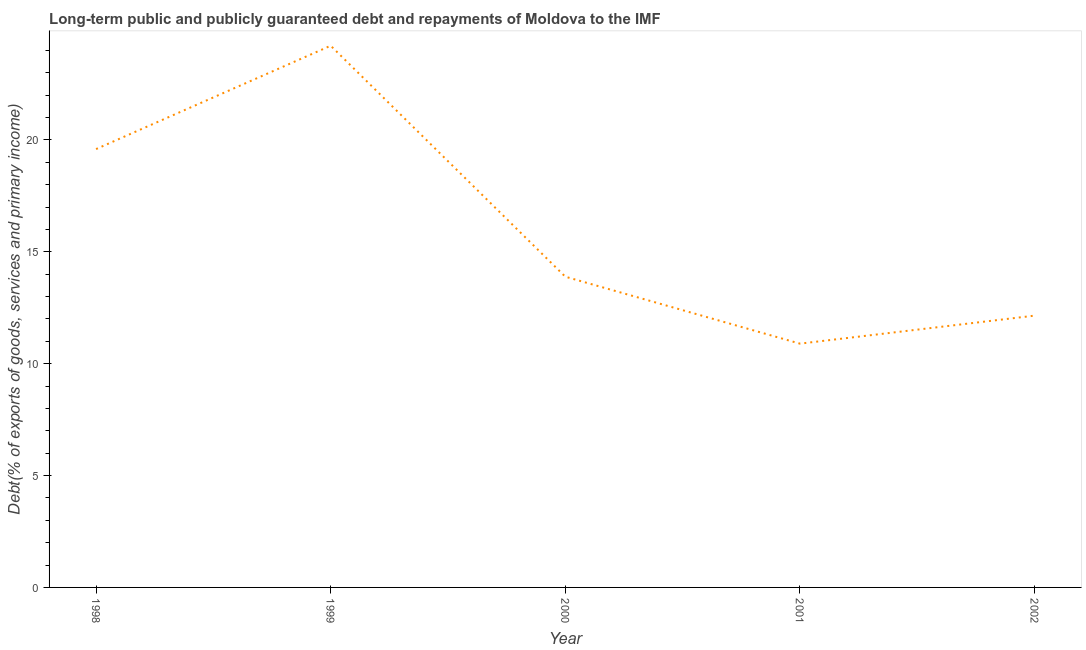What is the debt service in 2002?
Provide a short and direct response. 12.15. Across all years, what is the maximum debt service?
Give a very brief answer. 24.21. Across all years, what is the minimum debt service?
Provide a succinct answer. 10.9. In which year was the debt service maximum?
Provide a short and direct response. 1999. In which year was the debt service minimum?
Offer a terse response. 2001. What is the sum of the debt service?
Keep it short and to the point. 80.74. What is the difference between the debt service in 1999 and 2001?
Ensure brevity in your answer.  13.32. What is the average debt service per year?
Your answer should be very brief. 16.15. What is the median debt service?
Your answer should be compact. 13.89. In how many years, is the debt service greater than 14 %?
Your response must be concise. 2. Do a majority of the years between 1998 and 2001 (inclusive) have debt service greater than 15 %?
Make the answer very short. No. What is the ratio of the debt service in 1999 to that in 2002?
Ensure brevity in your answer.  1.99. What is the difference between the highest and the second highest debt service?
Provide a succinct answer. 4.62. Is the sum of the debt service in 1998 and 1999 greater than the maximum debt service across all years?
Your answer should be very brief. Yes. What is the difference between the highest and the lowest debt service?
Offer a very short reply. 13.32. How many lines are there?
Your answer should be very brief. 1. How many years are there in the graph?
Ensure brevity in your answer.  5. What is the difference between two consecutive major ticks on the Y-axis?
Make the answer very short. 5. Are the values on the major ticks of Y-axis written in scientific E-notation?
Provide a succinct answer. No. Does the graph contain any zero values?
Offer a very short reply. No. What is the title of the graph?
Offer a terse response. Long-term public and publicly guaranteed debt and repayments of Moldova to the IMF. What is the label or title of the X-axis?
Provide a succinct answer. Year. What is the label or title of the Y-axis?
Offer a terse response. Debt(% of exports of goods, services and primary income). What is the Debt(% of exports of goods, services and primary income) in 1998?
Make the answer very short. 19.59. What is the Debt(% of exports of goods, services and primary income) of 1999?
Your answer should be very brief. 24.21. What is the Debt(% of exports of goods, services and primary income) in 2000?
Keep it short and to the point. 13.89. What is the Debt(% of exports of goods, services and primary income) in 2001?
Provide a succinct answer. 10.9. What is the Debt(% of exports of goods, services and primary income) of 2002?
Give a very brief answer. 12.15. What is the difference between the Debt(% of exports of goods, services and primary income) in 1998 and 1999?
Provide a short and direct response. -4.62. What is the difference between the Debt(% of exports of goods, services and primary income) in 1998 and 2000?
Your response must be concise. 5.7. What is the difference between the Debt(% of exports of goods, services and primary income) in 1998 and 2001?
Ensure brevity in your answer.  8.7. What is the difference between the Debt(% of exports of goods, services and primary income) in 1998 and 2002?
Keep it short and to the point. 7.45. What is the difference between the Debt(% of exports of goods, services and primary income) in 1999 and 2000?
Offer a very short reply. 10.32. What is the difference between the Debt(% of exports of goods, services and primary income) in 1999 and 2001?
Your answer should be very brief. 13.32. What is the difference between the Debt(% of exports of goods, services and primary income) in 1999 and 2002?
Offer a terse response. 12.07. What is the difference between the Debt(% of exports of goods, services and primary income) in 2000 and 2001?
Offer a terse response. 2.99. What is the difference between the Debt(% of exports of goods, services and primary income) in 2000 and 2002?
Provide a succinct answer. 1.74. What is the difference between the Debt(% of exports of goods, services and primary income) in 2001 and 2002?
Keep it short and to the point. -1.25. What is the ratio of the Debt(% of exports of goods, services and primary income) in 1998 to that in 1999?
Ensure brevity in your answer.  0.81. What is the ratio of the Debt(% of exports of goods, services and primary income) in 1998 to that in 2000?
Provide a short and direct response. 1.41. What is the ratio of the Debt(% of exports of goods, services and primary income) in 1998 to that in 2001?
Offer a terse response. 1.8. What is the ratio of the Debt(% of exports of goods, services and primary income) in 1998 to that in 2002?
Your response must be concise. 1.61. What is the ratio of the Debt(% of exports of goods, services and primary income) in 1999 to that in 2000?
Your answer should be very brief. 1.74. What is the ratio of the Debt(% of exports of goods, services and primary income) in 1999 to that in 2001?
Offer a terse response. 2.22. What is the ratio of the Debt(% of exports of goods, services and primary income) in 1999 to that in 2002?
Provide a short and direct response. 1.99. What is the ratio of the Debt(% of exports of goods, services and primary income) in 2000 to that in 2001?
Provide a succinct answer. 1.27. What is the ratio of the Debt(% of exports of goods, services and primary income) in 2000 to that in 2002?
Offer a terse response. 1.14. What is the ratio of the Debt(% of exports of goods, services and primary income) in 2001 to that in 2002?
Offer a terse response. 0.9. 